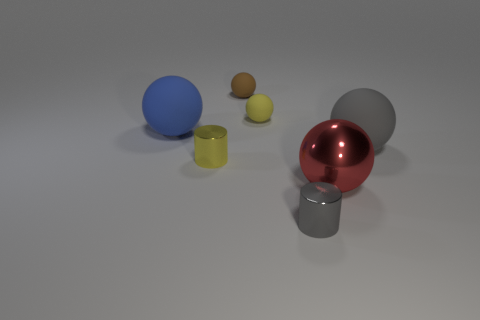Add 3 shiny spheres. How many objects exist? 10 Subtract all gray balls. How many balls are left? 4 Subtract all cylinders. How many objects are left? 5 Subtract 1 cylinders. How many cylinders are left? 1 Subtract all brown cylinders. Subtract all blue cubes. How many cylinders are left? 2 Subtract all red cylinders. How many blue balls are left? 1 Subtract all gray rubber spheres. Subtract all blue things. How many objects are left? 5 Add 4 gray objects. How many gray objects are left? 6 Add 3 large gray balls. How many large gray balls exist? 4 Subtract all brown spheres. How many spheres are left? 4 